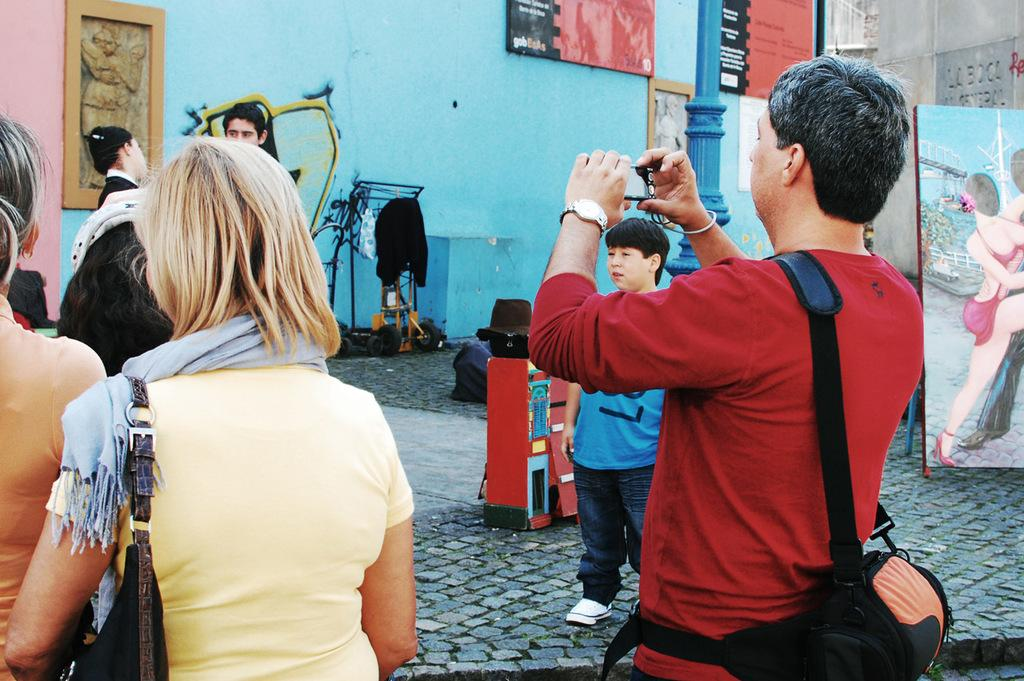What is happening with the group of persons in the image? The group of persons is standing on the floor. What can be seen in the background of the image? In the background, there are paintings, a kid, clothes, posters, a building, and a wall. Can you describe the setting of the image? The image appears to be set indoors, with a group of people standing on the floor and various items visible in the background. What type of salt is being used by the people in the image? There is no salt visible in the image, and it is not mentioned in the provided facts. What type of business is being conducted in the image? The image does not depict any business activities, and there is no mention of a business in the provided facts. 